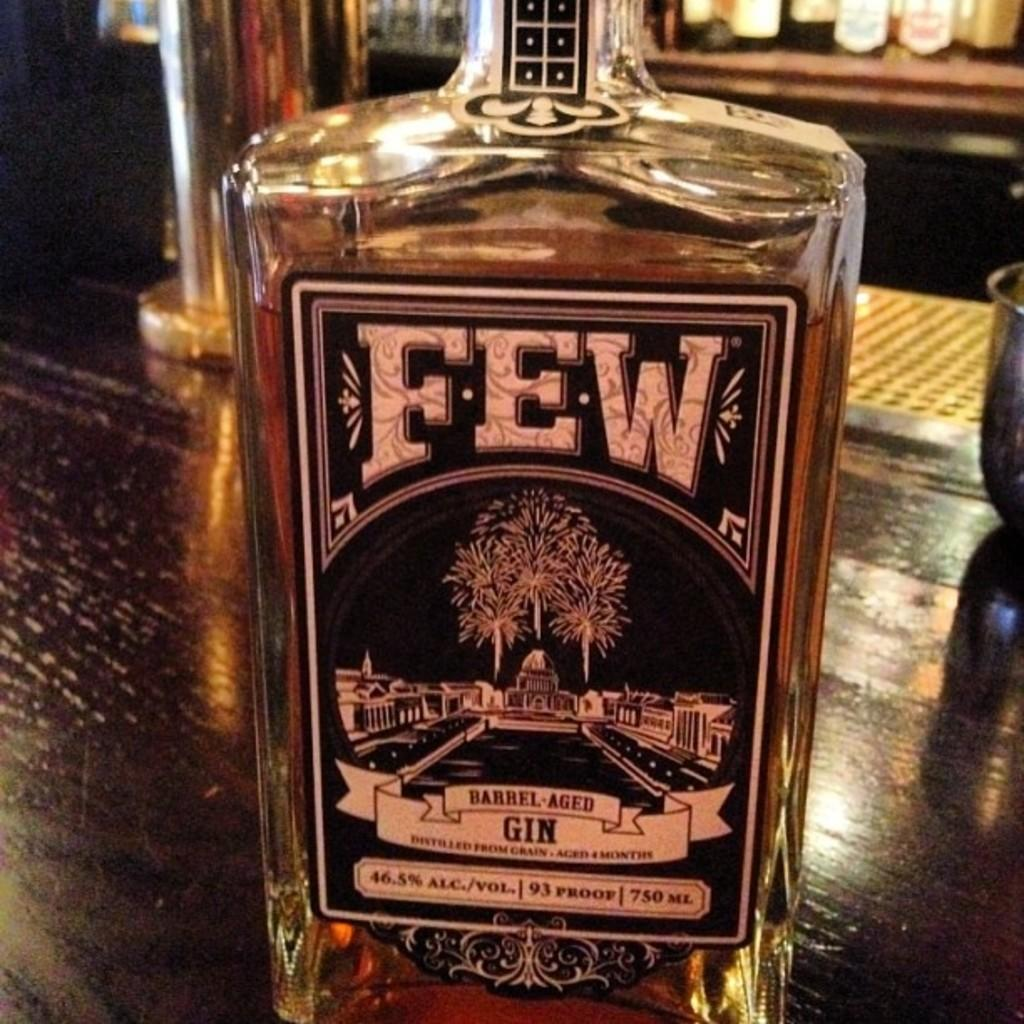What object can be seen on the table in the image? There is a bottle on the table in the image. What information is provided on the bottle? The bottle is labeled as "few." What additional detail can be observed on the bottle? There is a building as a logo on the label of the bottle. Where is the nearest zoo to the location depicted in the image? The image does not provide any information about the location or the presence of a zoo, so it cannot be determined from the image. 